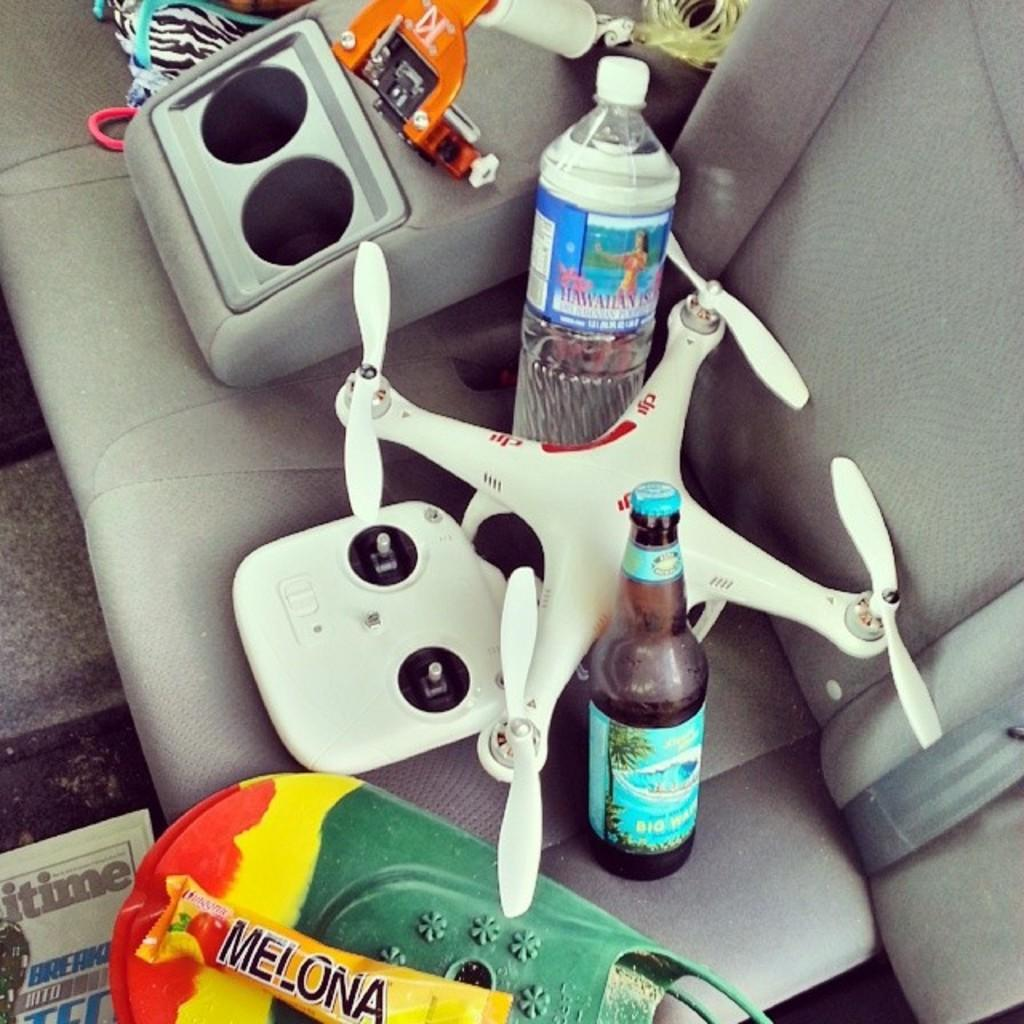<image>
Present a compact description of the photo's key features. A red, yellow and green object has Melona in black letters. 